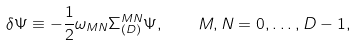Convert formula to latex. <formula><loc_0><loc_0><loc_500><loc_500>\delta \Psi \equiv - \frac { 1 } { 2 } \omega _ { M N } \Sigma _ { ( D ) } ^ { M N } \Psi , \quad M , N = 0 , \dots , D - 1 ,</formula> 